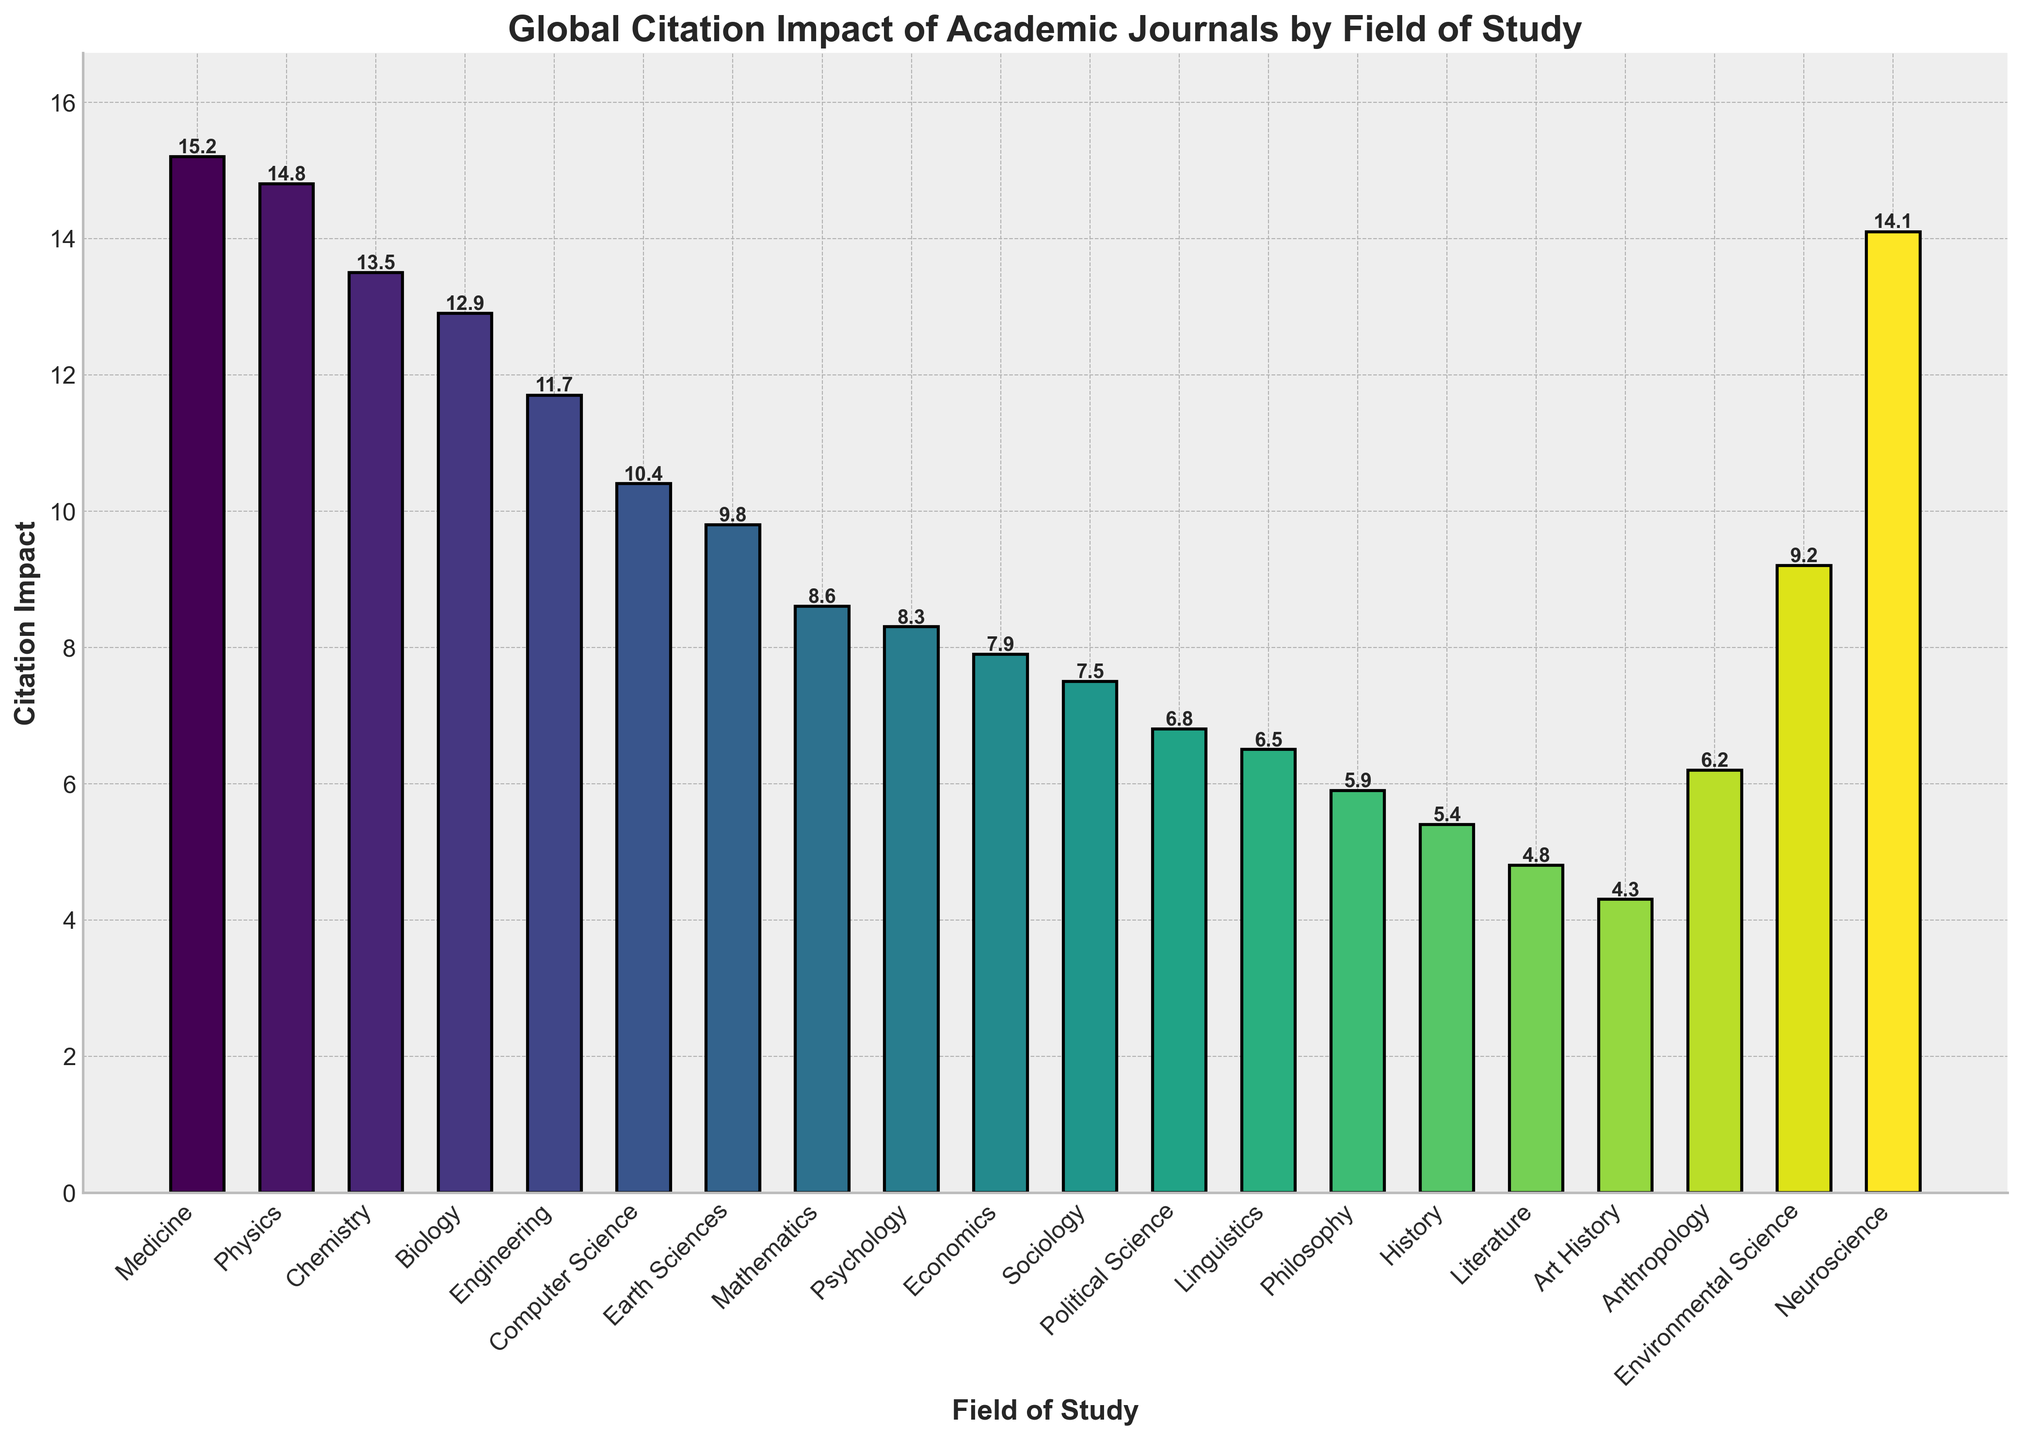Which field has the highest citation impact? The bar representing Medicine reaches the highest point on the vertical axis, indicating it has the highest citation impact.
Answer: Medicine Which two fields have citation impacts close to 14? The bars for Physics (14.8) and Neuroscience (14.1) are both close to the value 14.
Answer: Physics and Neuroscience What is the difference in citation impact between Physics and Computer Science? The citation impact of Physics is 14.8 and that of Computer Science is 10.4, so the difference is 14.8 - 10.4.
Answer: 4.4 How many fields have a citation impact greater than 10? By counting the bars that extend above the 10-mark on the vertical axis, there are 7 fields.
Answer: 7 What is the average citation impact of the top 5 fields? Adding the top 5 values (15.2 for Medicine, 14.8 for Physics, 14.1 for Neuroscience, 13.5 for Chemistry, and 12.9 for Biology) and then dividing by 5, the calculation is (15.2 + 14.8 + 14.1 + 13.5 + 12.9) / 5.
Answer: 14.1 Compare the citation impacts of Environmental Science and Earth Sciences. Which is higher? The bar for Earth Sciences reaches 9.8, while that of Environmental Science is 9.2, so Earth Sciences is higher.
Answer: Earth Sciences What is the median citation impact of all fields? To find the median, list all citation impacts in ascending order and find the middle value. With 19 fields, the median is the 10th value in the ordered list: [4.3, 4.8, 5.4, 5.9, 6.2, 6.5, 6.8, 7.5, 7.9, 8.3, 8.6, 9.2, 9.8, 10.4, 11.7, 12.9, 13.5, 14.1, 14.8, 15.2].
Answer: 8.3 Which field has the lowest citation impact, and what is that impact? The bar for Art History has the shortest height, representing the lowest citation impact.
Answer: Art History with 4.3 What is the total citation impact for Philosophy, History, and Literature combined? Adding the individual impacts: 5.9 (Philosophy) + 5.4 (History) + 4.8 (Literature).
Answer: 16.1 How does the citation impact of Sociology compare to that of Political Science? Sociology has a citation impact of 7.5, while Political Science has 6.8, so Sociology is higher.
Answer: Sociology 